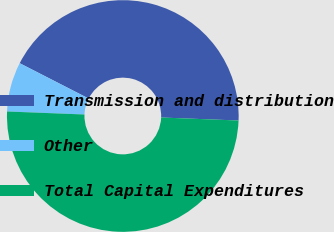<chart> <loc_0><loc_0><loc_500><loc_500><pie_chart><fcel>Transmission and distribution<fcel>Other<fcel>Total Capital Expenditures<nl><fcel>43.09%<fcel>6.91%<fcel>50.0%<nl></chart> 